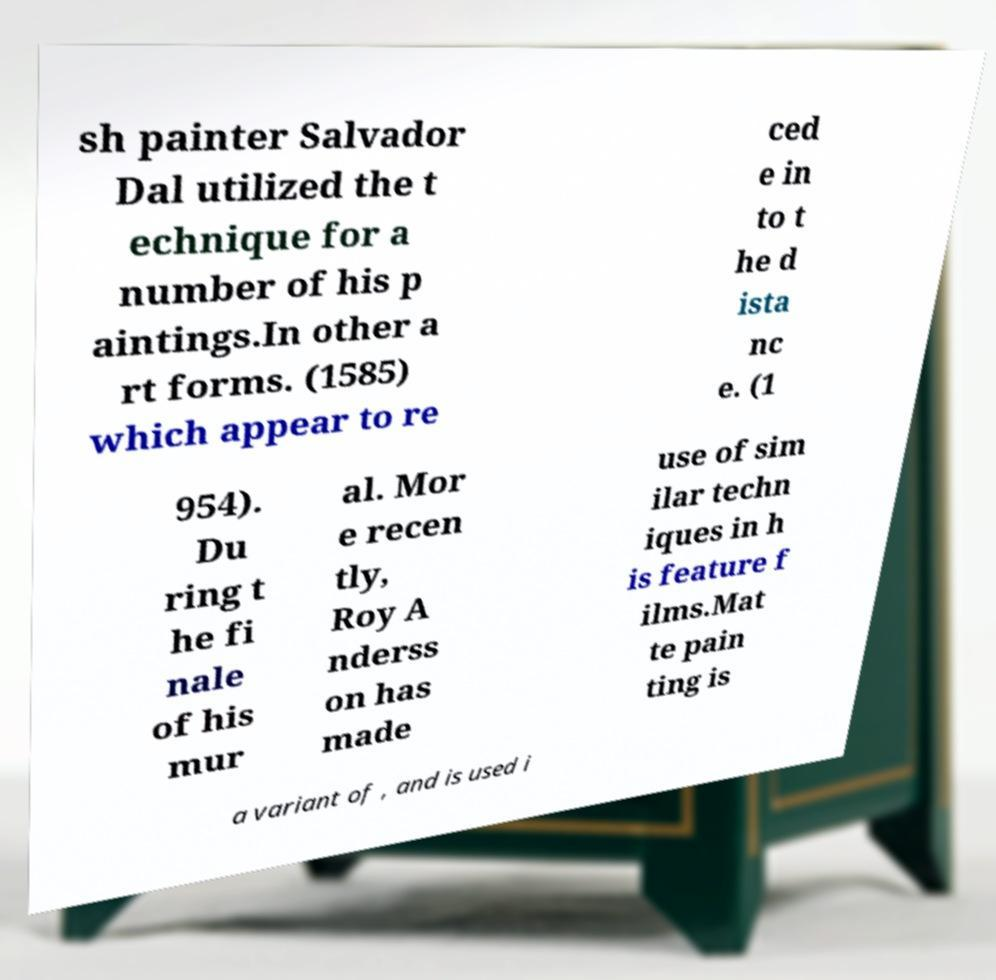For documentation purposes, I need the text within this image transcribed. Could you provide that? sh painter Salvador Dal utilized the t echnique for a number of his p aintings.In other a rt forms. (1585) which appear to re ced e in to t he d ista nc e. (1 954). Du ring t he fi nale of his mur al. Mor e recen tly, Roy A nderss on has made use of sim ilar techn iques in h is feature f ilms.Mat te pain ting is a variant of , and is used i 